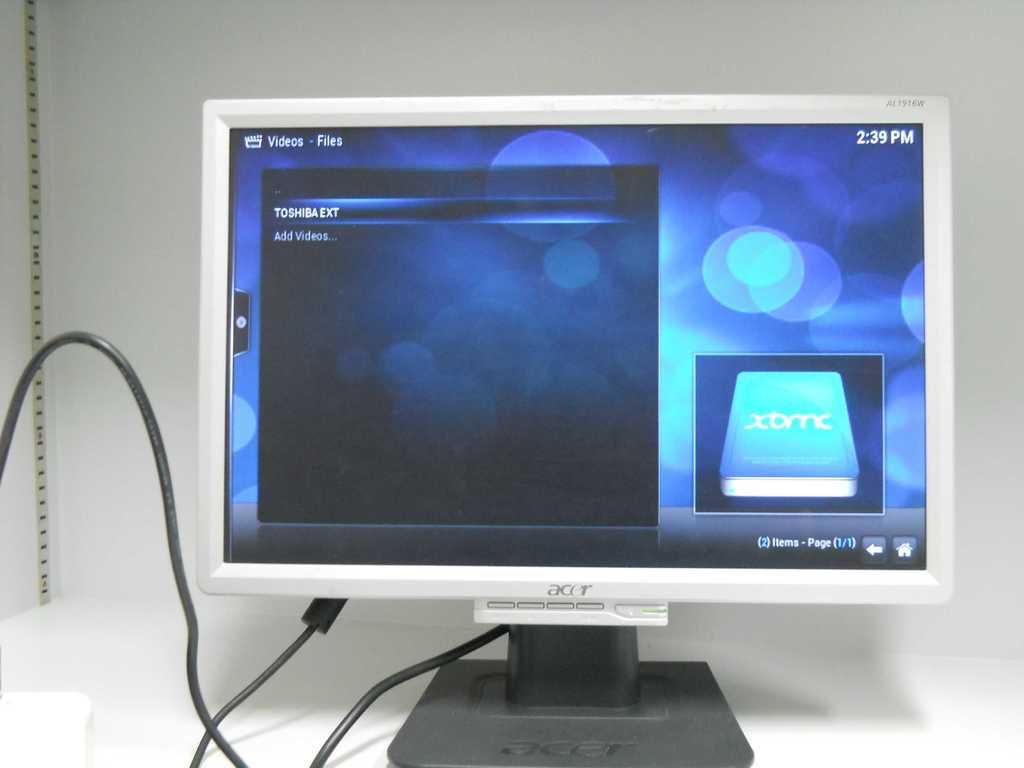Provide a one-sentence caption for the provided image. A computer monitor screen displaying a hard disk menu and the time. 